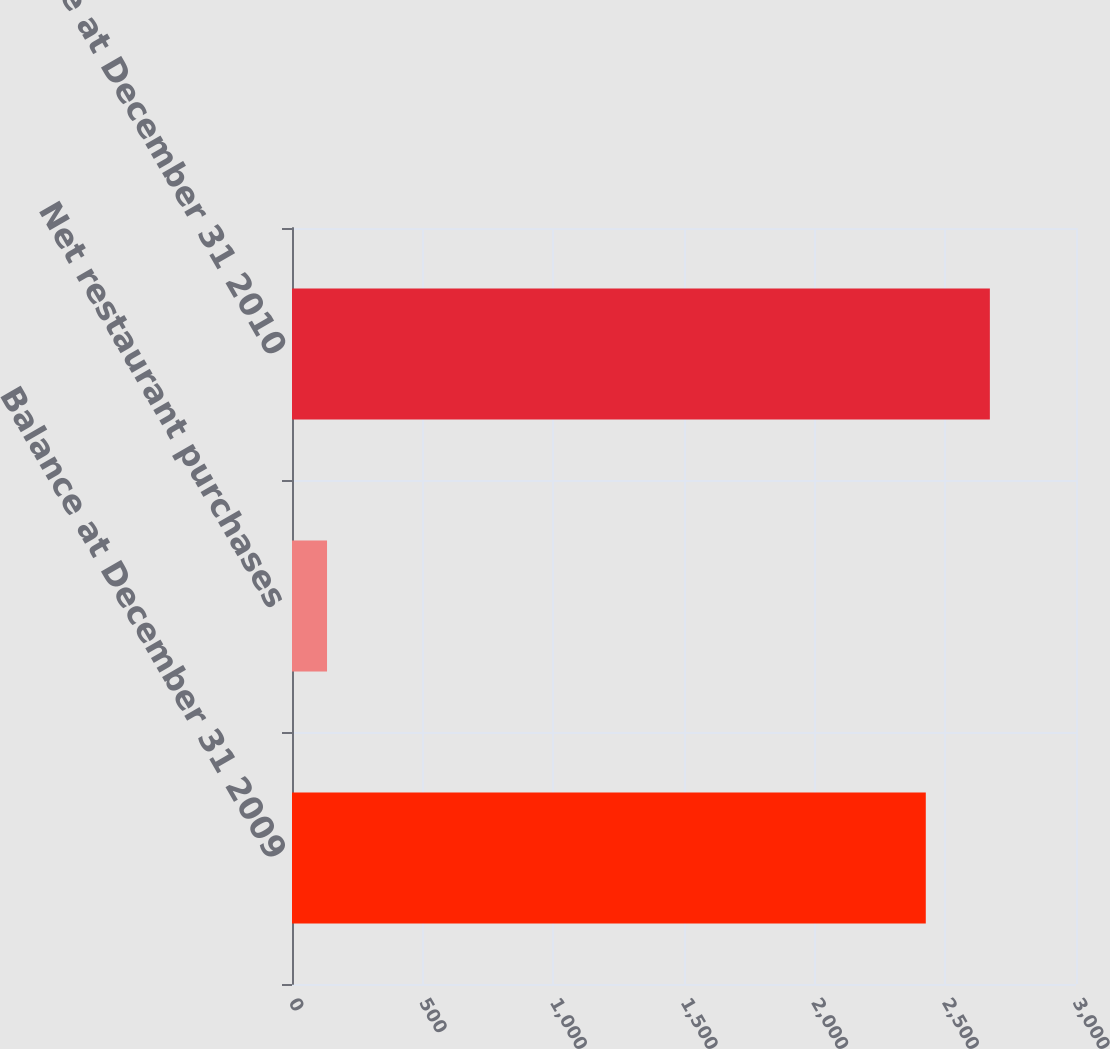<chart> <loc_0><loc_0><loc_500><loc_500><bar_chart><fcel>Balance at December 31 2009<fcel>Net restaurant purchases<fcel>Balance at December 31 2010<nl><fcel>2425.2<fcel>134.1<fcel>2670.4<nl></chart> 